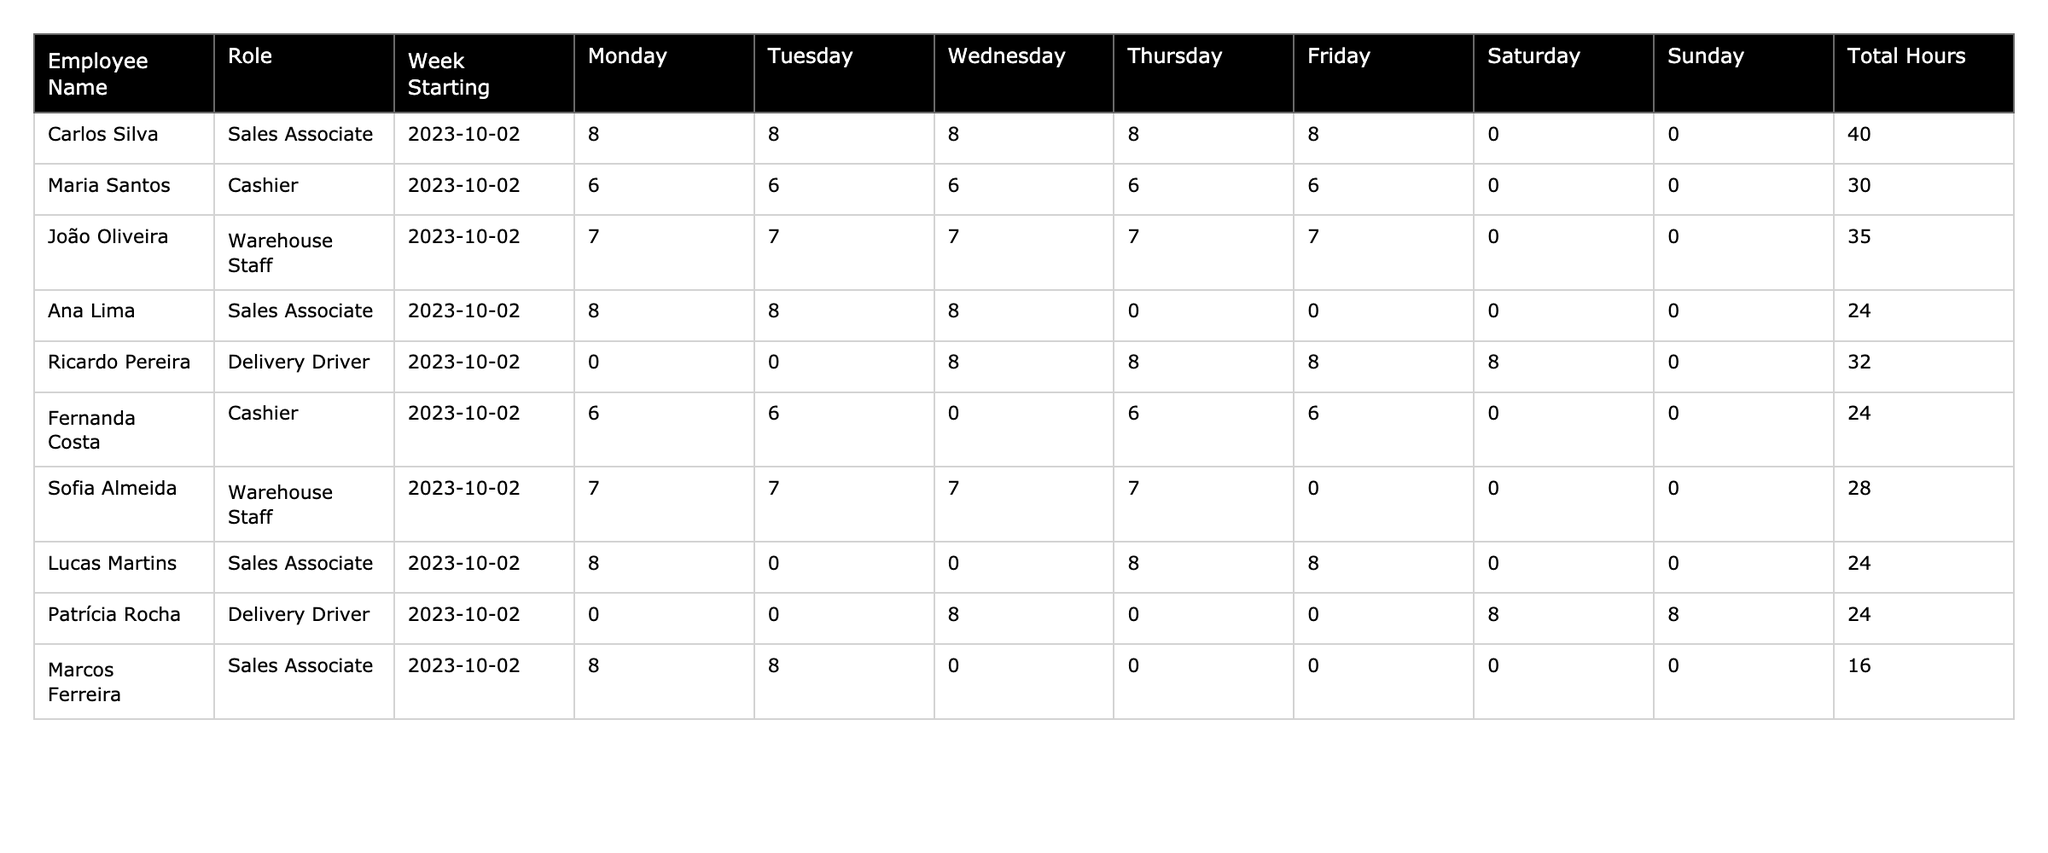What is the total number of hours worked by Carlos Silva? From the table, we can see that Carlos Silva worked a total of 40 hours in the week starting on October 2, 2023.
Answer: 40 How many hours did Maria Santos work on Thursday? Looking at the table, Maria Santos worked 6 hours on Thursday.
Answer: 6 Which employee worked the least number of total hours? By comparing the total hours for each employee, we find Marcos Ferreira worked the least, with a total of 16 hours.
Answer: Marcos Ferreira What is the total number of hours worked by all Sales Associates? Summing the total hours for Sales Associates: Carlos Silva (40) + Ana Lima (24) + Lucas Martins (24) + Marcos Ferreira (16) gives us 104 hours.
Answer: 104 Did any employee work on Sunday? The table shows that both Ricardo Pereira and Patrícia Rocha worked on Sunday, with each working 0 hours on that day.
Answer: Yes Who worked more hours: Delivery Drivers or Cashiers? Summing the hours, Delivery Drivers (Ricardo Pereira 32 + Patrícia Rocha 24 = 56) and Cashiers (Maria Santos 30 + Fernanda Costa 24 = 54). Delivery Drivers worked more hours.
Answer: Delivery Drivers What is the average number of hours worked by Warehouse Staff? The total hours for Warehouse Staff are João Oliveira (35) + Sofia Almeida (28) = 63 hours. There are 2 Warehouse Staff, so the average is 63/2 = 31.5 hours.
Answer: 31.5 Which day had the highest total hours worked across all employees? By adding the hours for each day: Monday (40+6+7+8+0+6+7+8+0+8 = 90), Tuesday (8+6+7+8+0+6+7+0+0+8 = 64), Wednesday (8+6+7+8+8+0+7+8+8+0 = 70), Thursday (8+6+0+0+8+6+7+0+0+0 = 35), Friday (8+6+6+0+8+6+0+0+0+0 = 34), Saturday and Sunday have 0. Therefore, Monday had the highest total with 90 hours.
Answer: Monday What is the total work hours for employees who did not work on Saturday? The employees who did not work on Saturday are Carlos Silva (40) + Maria Santos (30) + Ana Lima (24) + Sofia Almeida (28) + Marcos Ferreira (16), adding these gives 138 total hours.
Answer: 138 